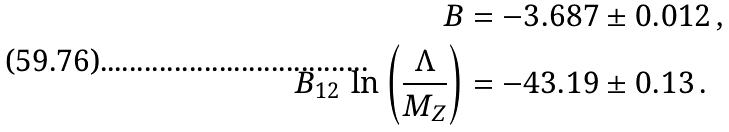Convert formula to latex. <formula><loc_0><loc_0><loc_500><loc_500>B & = - 3 . 6 8 7 \pm 0 . 0 1 2 \, , \\ B _ { 1 2 } \, \ln \left ( \frac { \Lambda } { M _ { Z } } \right ) & = - 4 3 . 1 9 \pm 0 . 1 3 \, .</formula> 